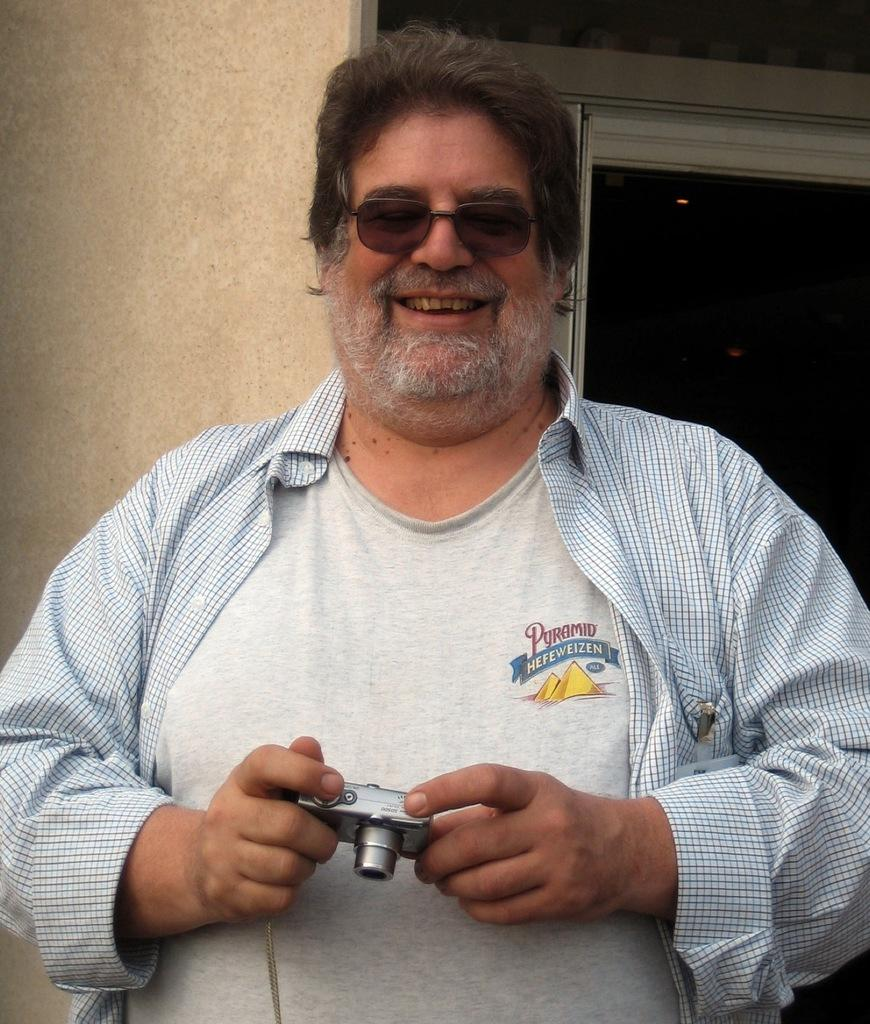What type of structure can be seen in the image? There is a wall in the image. Is there any opening in the wall? Yes, there is a window in the image. Who is present in the image? There is a woman in the image. What is the woman wearing? The woman is wearing a white t-shirt. What is the woman holding in the image? The woman is holding a camera. What type of party is happening in the image? There is no party happening in the image; it only features a woman standing near a wall with a window. Can you tell me how the woman is performing a trick in the image? There is no trick being performed by the woman in the image; she is simply holding a camera. 